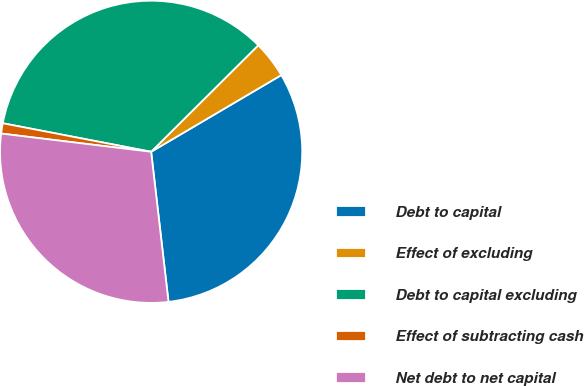Convert chart. <chart><loc_0><loc_0><loc_500><loc_500><pie_chart><fcel>Debt to capital<fcel>Effect of excluding<fcel>Debt to capital excluding<fcel>Effect of subtracting cash<fcel>Net debt to net capital<nl><fcel>31.64%<fcel>3.98%<fcel>34.52%<fcel>1.1%<fcel>28.76%<nl></chart> 